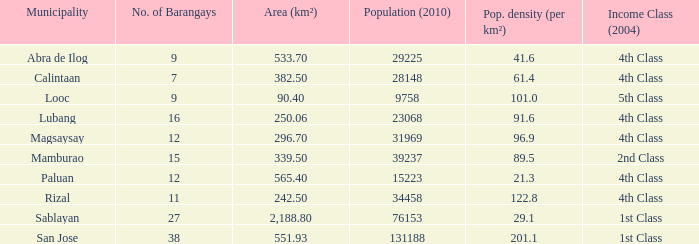List the population density per kilometer for the city of abra de ilog. 41.6. 